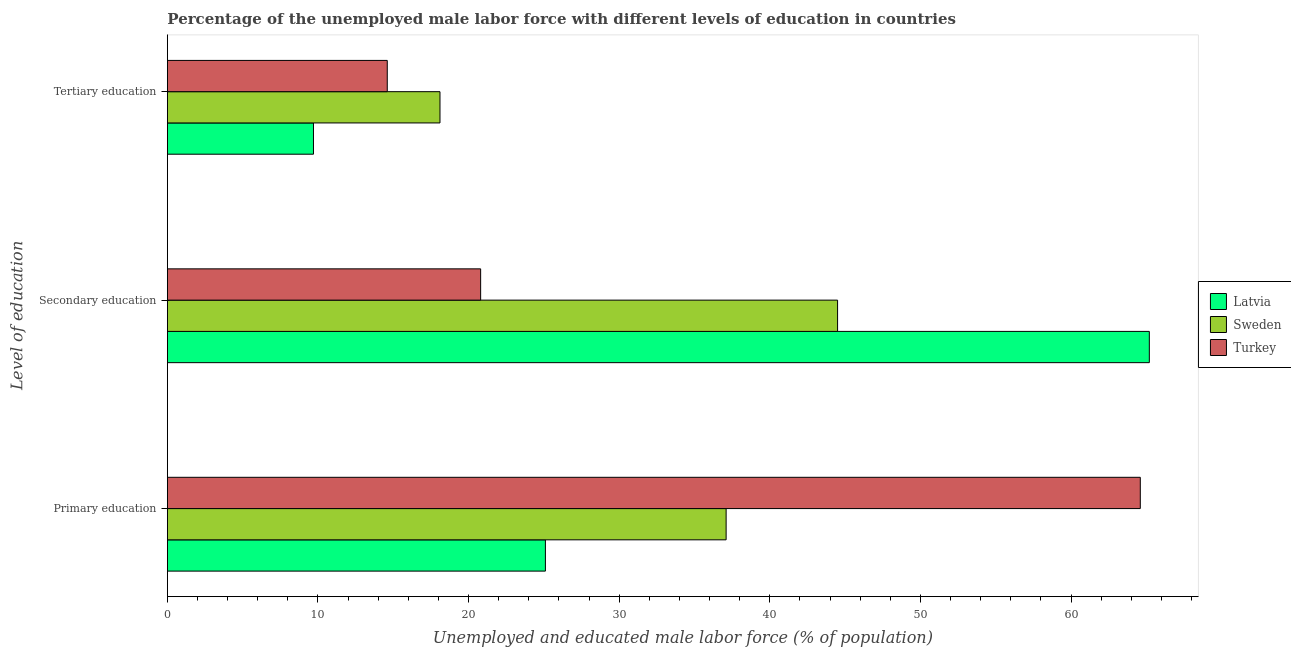Are the number of bars on each tick of the Y-axis equal?
Offer a terse response. Yes. How many bars are there on the 2nd tick from the top?
Your answer should be compact. 3. How many bars are there on the 2nd tick from the bottom?
Provide a short and direct response. 3. What is the label of the 2nd group of bars from the top?
Ensure brevity in your answer.  Secondary education. What is the percentage of male labor force who received secondary education in Sweden?
Your answer should be very brief. 44.5. Across all countries, what is the maximum percentage of male labor force who received tertiary education?
Make the answer very short. 18.1. Across all countries, what is the minimum percentage of male labor force who received tertiary education?
Make the answer very short. 9.7. What is the total percentage of male labor force who received tertiary education in the graph?
Offer a terse response. 42.4. What is the difference between the percentage of male labor force who received primary education in Latvia and that in Sweden?
Provide a succinct answer. -12. What is the difference between the percentage of male labor force who received secondary education in Latvia and the percentage of male labor force who received tertiary education in Sweden?
Ensure brevity in your answer.  47.1. What is the average percentage of male labor force who received primary education per country?
Your response must be concise. 42.27. What is the difference between the percentage of male labor force who received tertiary education and percentage of male labor force who received primary education in Sweden?
Provide a short and direct response. -19. What is the ratio of the percentage of male labor force who received primary education in Sweden to that in Turkey?
Make the answer very short. 0.57. What is the difference between the highest and the second highest percentage of male labor force who received secondary education?
Provide a short and direct response. 20.7. What is the difference between the highest and the lowest percentage of male labor force who received tertiary education?
Keep it short and to the point. 8.4. In how many countries, is the percentage of male labor force who received tertiary education greater than the average percentage of male labor force who received tertiary education taken over all countries?
Provide a succinct answer. 2. What does the 2nd bar from the top in Secondary education represents?
Your answer should be compact. Sweden. What does the 1st bar from the bottom in Secondary education represents?
Your answer should be compact. Latvia. Is it the case that in every country, the sum of the percentage of male labor force who received primary education and percentage of male labor force who received secondary education is greater than the percentage of male labor force who received tertiary education?
Your answer should be very brief. Yes. How many countries are there in the graph?
Your answer should be very brief. 3. What is the difference between two consecutive major ticks on the X-axis?
Your answer should be compact. 10. Are the values on the major ticks of X-axis written in scientific E-notation?
Ensure brevity in your answer.  No. Does the graph contain any zero values?
Offer a very short reply. No. How are the legend labels stacked?
Offer a terse response. Vertical. What is the title of the graph?
Make the answer very short. Percentage of the unemployed male labor force with different levels of education in countries. Does "Equatorial Guinea" appear as one of the legend labels in the graph?
Keep it short and to the point. No. What is the label or title of the X-axis?
Give a very brief answer. Unemployed and educated male labor force (% of population). What is the label or title of the Y-axis?
Ensure brevity in your answer.  Level of education. What is the Unemployed and educated male labor force (% of population) in Latvia in Primary education?
Keep it short and to the point. 25.1. What is the Unemployed and educated male labor force (% of population) of Sweden in Primary education?
Provide a short and direct response. 37.1. What is the Unemployed and educated male labor force (% of population) in Turkey in Primary education?
Offer a very short reply. 64.6. What is the Unemployed and educated male labor force (% of population) in Latvia in Secondary education?
Ensure brevity in your answer.  65.2. What is the Unemployed and educated male labor force (% of population) of Sweden in Secondary education?
Provide a succinct answer. 44.5. What is the Unemployed and educated male labor force (% of population) in Turkey in Secondary education?
Ensure brevity in your answer.  20.8. What is the Unemployed and educated male labor force (% of population) in Latvia in Tertiary education?
Ensure brevity in your answer.  9.7. What is the Unemployed and educated male labor force (% of population) in Sweden in Tertiary education?
Your answer should be compact. 18.1. What is the Unemployed and educated male labor force (% of population) of Turkey in Tertiary education?
Offer a terse response. 14.6. Across all Level of education, what is the maximum Unemployed and educated male labor force (% of population) of Latvia?
Your response must be concise. 65.2. Across all Level of education, what is the maximum Unemployed and educated male labor force (% of population) of Sweden?
Ensure brevity in your answer.  44.5. Across all Level of education, what is the maximum Unemployed and educated male labor force (% of population) of Turkey?
Give a very brief answer. 64.6. Across all Level of education, what is the minimum Unemployed and educated male labor force (% of population) of Latvia?
Your answer should be very brief. 9.7. Across all Level of education, what is the minimum Unemployed and educated male labor force (% of population) in Sweden?
Your answer should be very brief. 18.1. Across all Level of education, what is the minimum Unemployed and educated male labor force (% of population) in Turkey?
Offer a terse response. 14.6. What is the total Unemployed and educated male labor force (% of population) in Sweden in the graph?
Keep it short and to the point. 99.7. What is the difference between the Unemployed and educated male labor force (% of population) in Latvia in Primary education and that in Secondary education?
Offer a very short reply. -40.1. What is the difference between the Unemployed and educated male labor force (% of population) in Turkey in Primary education and that in Secondary education?
Your response must be concise. 43.8. What is the difference between the Unemployed and educated male labor force (% of population) of Turkey in Primary education and that in Tertiary education?
Ensure brevity in your answer.  50. What is the difference between the Unemployed and educated male labor force (% of population) of Latvia in Secondary education and that in Tertiary education?
Keep it short and to the point. 55.5. What is the difference between the Unemployed and educated male labor force (% of population) in Sweden in Secondary education and that in Tertiary education?
Make the answer very short. 26.4. What is the difference between the Unemployed and educated male labor force (% of population) of Latvia in Primary education and the Unemployed and educated male labor force (% of population) of Sweden in Secondary education?
Your answer should be compact. -19.4. What is the difference between the Unemployed and educated male labor force (% of population) in Sweden in Primary education and the Unemployed and educated male labor force (% of population) in Turkey in Secondary education?
Your answer should be very brief. 16.3. What is the difference between the Unemployed and educated male labor force (% of population) in Latvia in Primary education and the Unemployed and educated male labor force (% of population) in Sweden in Tertiary education?
Provide a succinct answer. 7. What is the difference between the Unemployed and educated male labor force (% of population) in Latvia in Primary education and the Unemployed and educated male labor force (% of population) in Turkey in Tertiary education?
Offer a very short reply. 10.5. What is the difference between the Unemployed and educated male labor force (% of population) in Latvia in Secondary education and the Unemployed and educated male labor force (% of population) in Sweden in Tertiary education?
Provide a short and direct response. 47.1. What is the difference between the Unemployed and educated male labor force (% of population) of Latvia in Secondary education and the Unemployed and educated male labor force (% of population) of Turkey in Tertiary education?
Your answer should be very brief. 50.6. What is the difference between the Unemployed and educated male labor force (% of population) in Sweden in Secondary education and the Unemployed and educated male labor force (% of population) in Turkey in Tertiary education?
Offer a terse response. 29.9. What is the average Unemployed and educated male labor force (% of population) of Latvia per Level of education?
Your response must be concise. 33.33. What is the average Unemployed and educated male labor force (% of population) in Sweden per Level of education?
Give a very brief answer. 33.23. What is the average Unemployed and educated male labor force (% of population) of Turkey per Level of education?
Your response must be concise. 33.33. What is the difference between the Unemployed and educated male labor force (% of population) in Latvia and Unemployed and educated male labor force (% of population) in Sweden in Primary education?
Provide a short and direct response. -12. What is the difference between the Unemployed and educated male labor force (% of population) in Latvia and Unemployed and educated male labor force (% of population) in Turkey in Primary education?
Your answer should be compact. -39.5. What is the difference between the Unemployed and educated male labor force (% of population) in Sweden and Unemployed and educated male labor force (% of population) in Turkey in Primary education?
Make the answer very short. -27.5. What is the difference between the Unemployed and educated male labor force (% of population) in Latvia and Unemployed and educated male labor force (% of population) in Sweden in Secondary education?
Make the answer very short. 20.7. What is the difference between the Unemployed and educated male labor force (% of population) of Latvia and Unemployed and educated male labor force (% of population) of Turkey in Secondary education?
Ensure brevity in your answer.  44.4. What is the difference between the Unemployed and educated male labor force (% of population) of Sweden and Unemployed and educated male labor force (% of population) of Turkey in Secondary education?
Give a very brief answer. 23.7. What is the difference between the Unemployed and educated male labor force (% of population) of Latvia and Unemployed and educated male labor force (% of population) of Sweden in Tertiary education?
Keep it short and to the point. -8.4. What is the difference between the Unemployed and educated male labor force (% of population) in Sweden and Unemployed and educated male labor force (% of population) in Turkey in Tertiary education?
Provide a short and direct response. 3.5. What is the ratio of the Unemployed and educated male labor force (% of population) in Latvia in Primary education to that in Secondary education?
Your answer should be compact. 0.39. What is the ratio of the Unemployed and educated male labor force (% of population) of Sweden in Primary education to that in Secondary education?
Offer a very short reply. 0.83. What is the ratio of the Unemployed and educated male labor force (% of population) of Turkey in Primary education to that in Secondary education?
Provide a short and direct response. 3.11. What is the ratio of the Unemployed and educated male labor force (% of population) in Latvia in Primary education to that in Tertiary education?
Provide a short and direct response. 2.59. What is the ratio of the Unemployed and educated male labor force (% of population) of Sweden in Primary education to that in Tertiary education?
Make the answer very short. 2.05. What is the ratio of the Unemployed and educated male labor force (% of population) in Turkey in Primary education to that in Tertiary education?
Keep it short and to the point. 4.42. What is the ratio of the Unemployed and educated male labor force (% of population) in Latvia in Secondary education to that in Tertiary education?
Make the answer very short. 6.72. What is the ratio of the Unemployed and educated male labor force (% of population) of Sweden in Secondary education to that in Tertiary education?
Offer a very short reply. 2.46. What is the ratio of the Unemployed and educated male labor force (% of population) in Turkey in Secondary education to that in Tertiary education?
Your answer should be compact. 1.42. What is the difference between the highest and the second highest Unemployed and educated male labor force (% of population) in Latvia?
Your answer should be very brief. 40.1. What is the difference between the highest and the second highest Unemployed and educated male labor force (% of population) of Sweden?
Make the answer very short. 7.4. What is the difference between the highest and the second highest Unemployed and educated male labor force (% of population) of Turkey?
Your answer should be compact. 43.8. What is the difference between the highest and the lowest Unemployed and educated male labor force (% of population) of Latvia?
Provide a succinct answer. 55.5. What is the difference between the highest and the lowest Unemployed and educated male labor force (% of population) in Sweden?
Provide a short and direct response. 26.4. What is the difference between the highest and the lowest Unemployed and educated male labor force (% of population) in Turkey?
Offer a terse response. 50. 